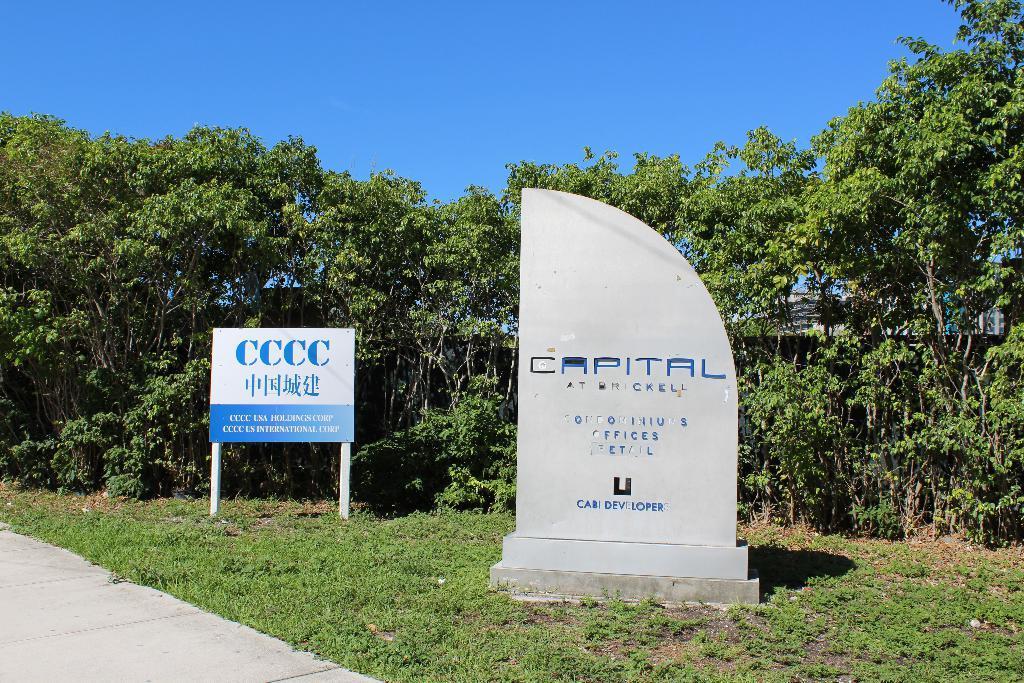How would you summarize this image in a sentence or two? In the image there is a grass surface and on that there is a stone and on the stone there are some names and on the left side there is a board, on the board there is some text and logo. In the background there are trees. 